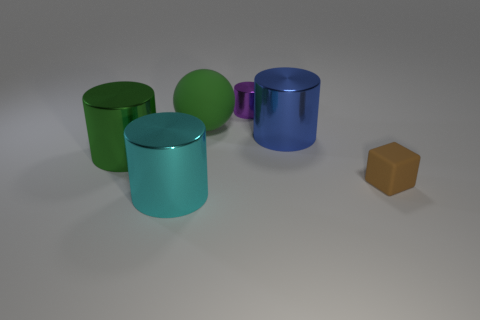There is a shiny cylinder left of the cyan thing; is its color the same as the ball? The shiny cylinder to the left of the cyan object is not the same color as the ball. While it does share a similar sheen and reflective quality, the cylinder has a green hue, and the ball is a distinct cyan. The ball's color is consistent throughout its surface, whereas the cylinder's reflective nature may create slight variations in its green tone depending on the viewing angle and lighting conditions. 